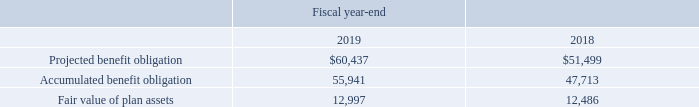14. DEFINED BENEFIT PLANS (Continued)
The information for plans with an accumulated benefit obligation in excess of plan assets is as follows (in thousands):
What was the Projected benefit obligation in 2019?
Answer scale should be: thousand. $60,437. What was the  Accumulated benefit obligation  in 2018?
Answer scale should be: thousand. 47,713. In which years was information on defined benefit plans provided? 2019, 2018. In which year was the Fair value of plan assets larger? 12,997>12,486
Answer: 2019. What was the change in Fair value of plan assets from 2018 to 2019?
Answer scale should be: thousand. 12,997-12,486
Answer: 511. What was the percentage change in Fair value of plan assets from 2018 to 2019?
Answer scale should be: percent. (12,997-12,486)/12,486
Answer: 4.09. 